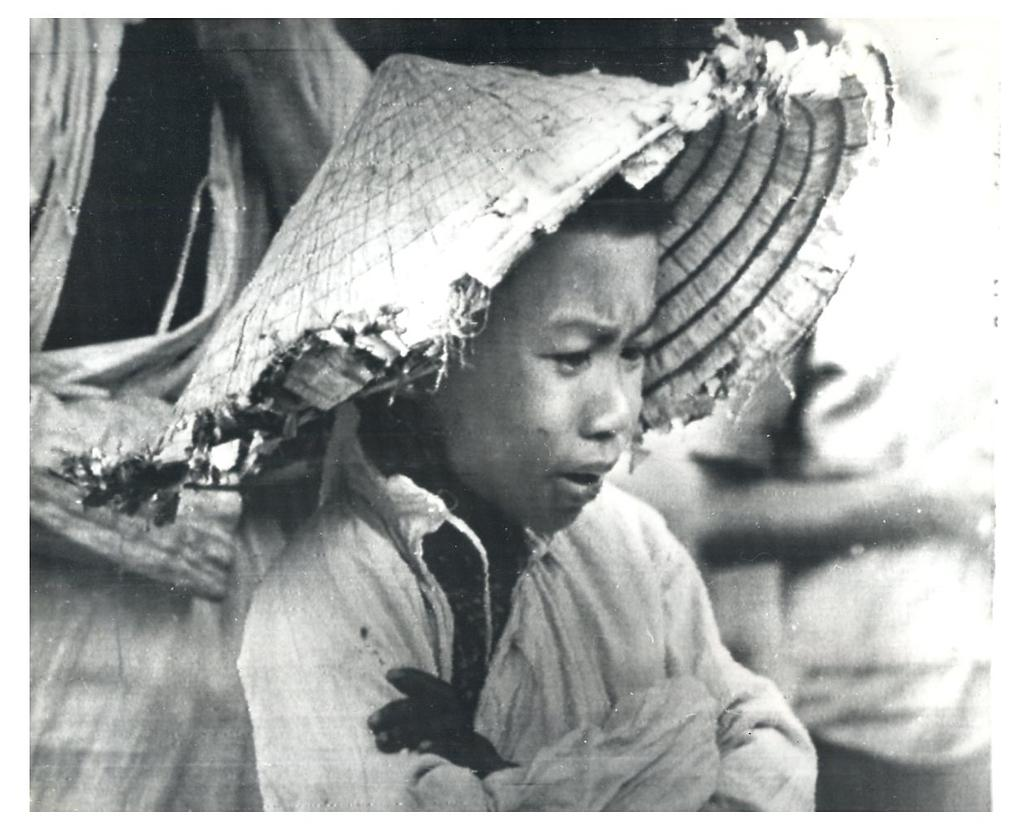What is the main subject of the image? There is a person standing in the image. What is the person wearing on their head? The person is wearing a cap. What is the color scheme of the image? The image is in black and white. How many horses are visible in the image? There are no horses present in the image. What type of can is being used by the person in the image? There is no can visible in the image. 